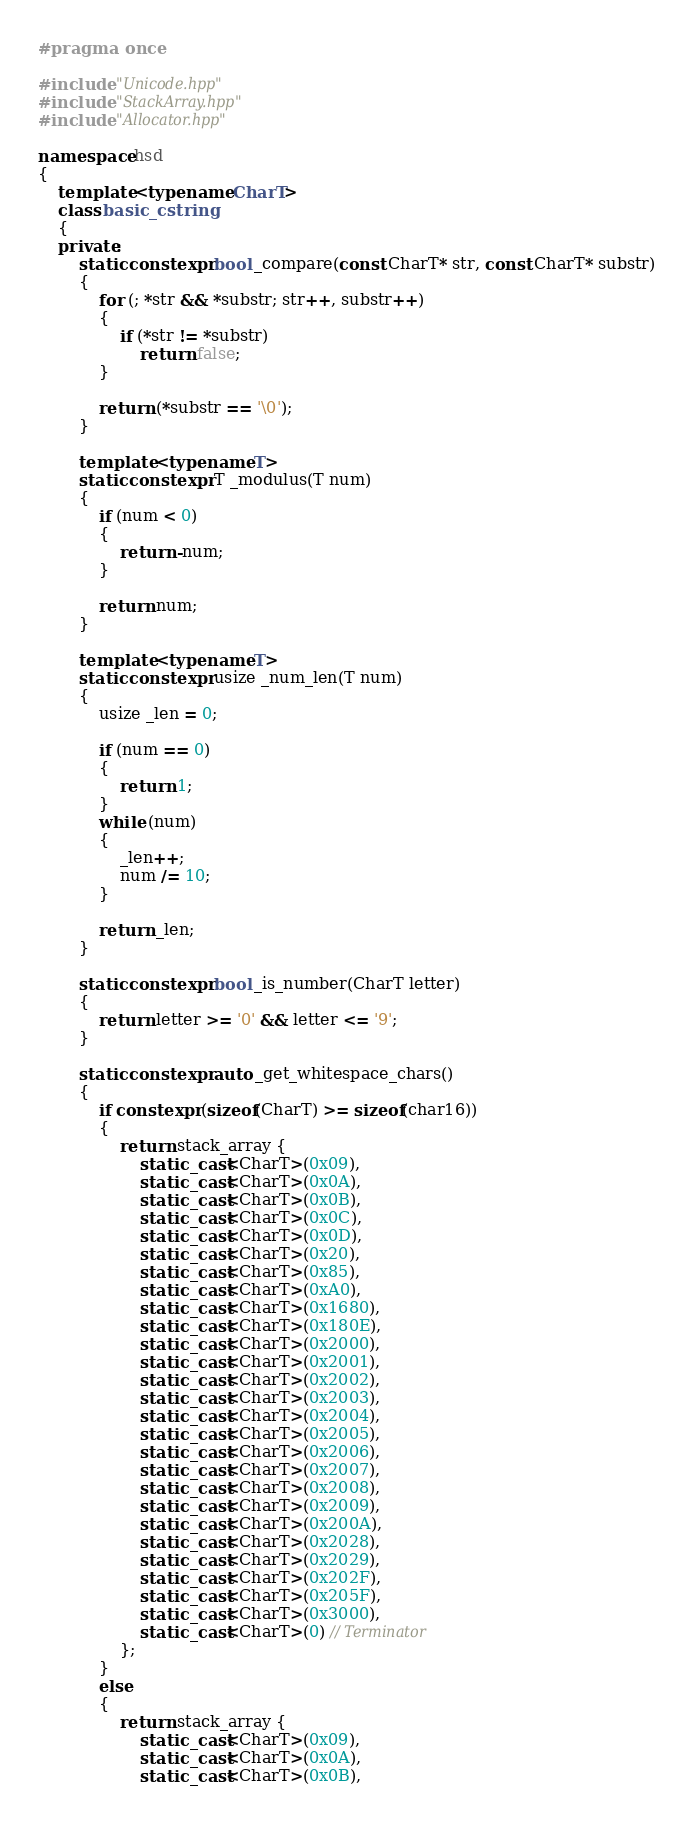Convert code to text. <code><loc_0><loc_0><loc_500><loc_500><_C++_>#pragma once

#include "Unicode.hpp"
#include "StackArray.hpp"
#include "Allocator.hpp"

namespace hsd
{	
    template <typename CharT>
    class basic_cstring
    {
    private:
        static constexpr bool _compare(const CharT* str, const CharT* substr)
        {
            for (; *str && *substr; str++, substr++)
            {
                if (*str != *substr)
                    return false;
            }

            return (*substr == '\0');
        }

        template <typename T>
        static constexpr T _modulus(T num)
        {
            if (num < 0)
            {
                return -num;
            }

            return num;
        }

        template <typename T>
        static constexpr usize _num_len(T num)
        {
            usize _len = 0;
            
            if (num == 0)
            {
                return 1;
            }
            while (num)
            {
                _len++;
                num /= 10;
            }

            return _len;
        }

        static constexpr bool _is_number(CharT letter)
        {
            return letter >= '0' && letter <= '9';
        }

        static constexpr auto _get_whitespace_chars()
        {
            if constexpr (sizeof(CharT) >= sizeof(char16))
            {
                return stack_array {
                    static_cast<CharT>(0x09),
                    static_cast<CharT>(0x0A),
                    static_cast<CharT>(0x0B),
                    static_cast<CharT>(0x0C),
                    static_cast<CharT>(0x0D),
                    static_cast<CharT>(0x20),
                    static_cast<CharT>(0x85),
                    static_cast<CharT>(0xA0),
                    static_cast<CharT>(0x1680),
                    static_cast<CharT>(0x180E),
                    static_cast<CharT>(0x2000),
                    static_cast<CharT>(0x2001),
                    static_cast<CharT>(0x2002),
                    static_cast<CharT>(0x2003),
                    static_cast<CharT>(0x2004),
                    static_cast<CharT>(0x2005),
                    static_cast<CharT>(0x2006),
                    static_cast<CharT>(0x2007),
                    static_cast<CharT>(0x2008),
                    static_cast<CharT>(0x2009),
                    static_cast<CharT>(0x200A),
                    static_cast<CharT>(0x2028),
                    static_cast<CharT>(0x2029),
                    static_cast<CharT>(0x202F),
                    static_cast<CharT>(0x205F),
                    static_cast<CharT>(0x3000),
                    static_cast<CharT>(0) // Terminator
                };
            } 
            else 
            {
                return stack_array {
                    static_cast<CharT>(0x09),
                    static_cast<CharT>(0x0A),
                    static_cast<CharT>(0x0B),</code> 